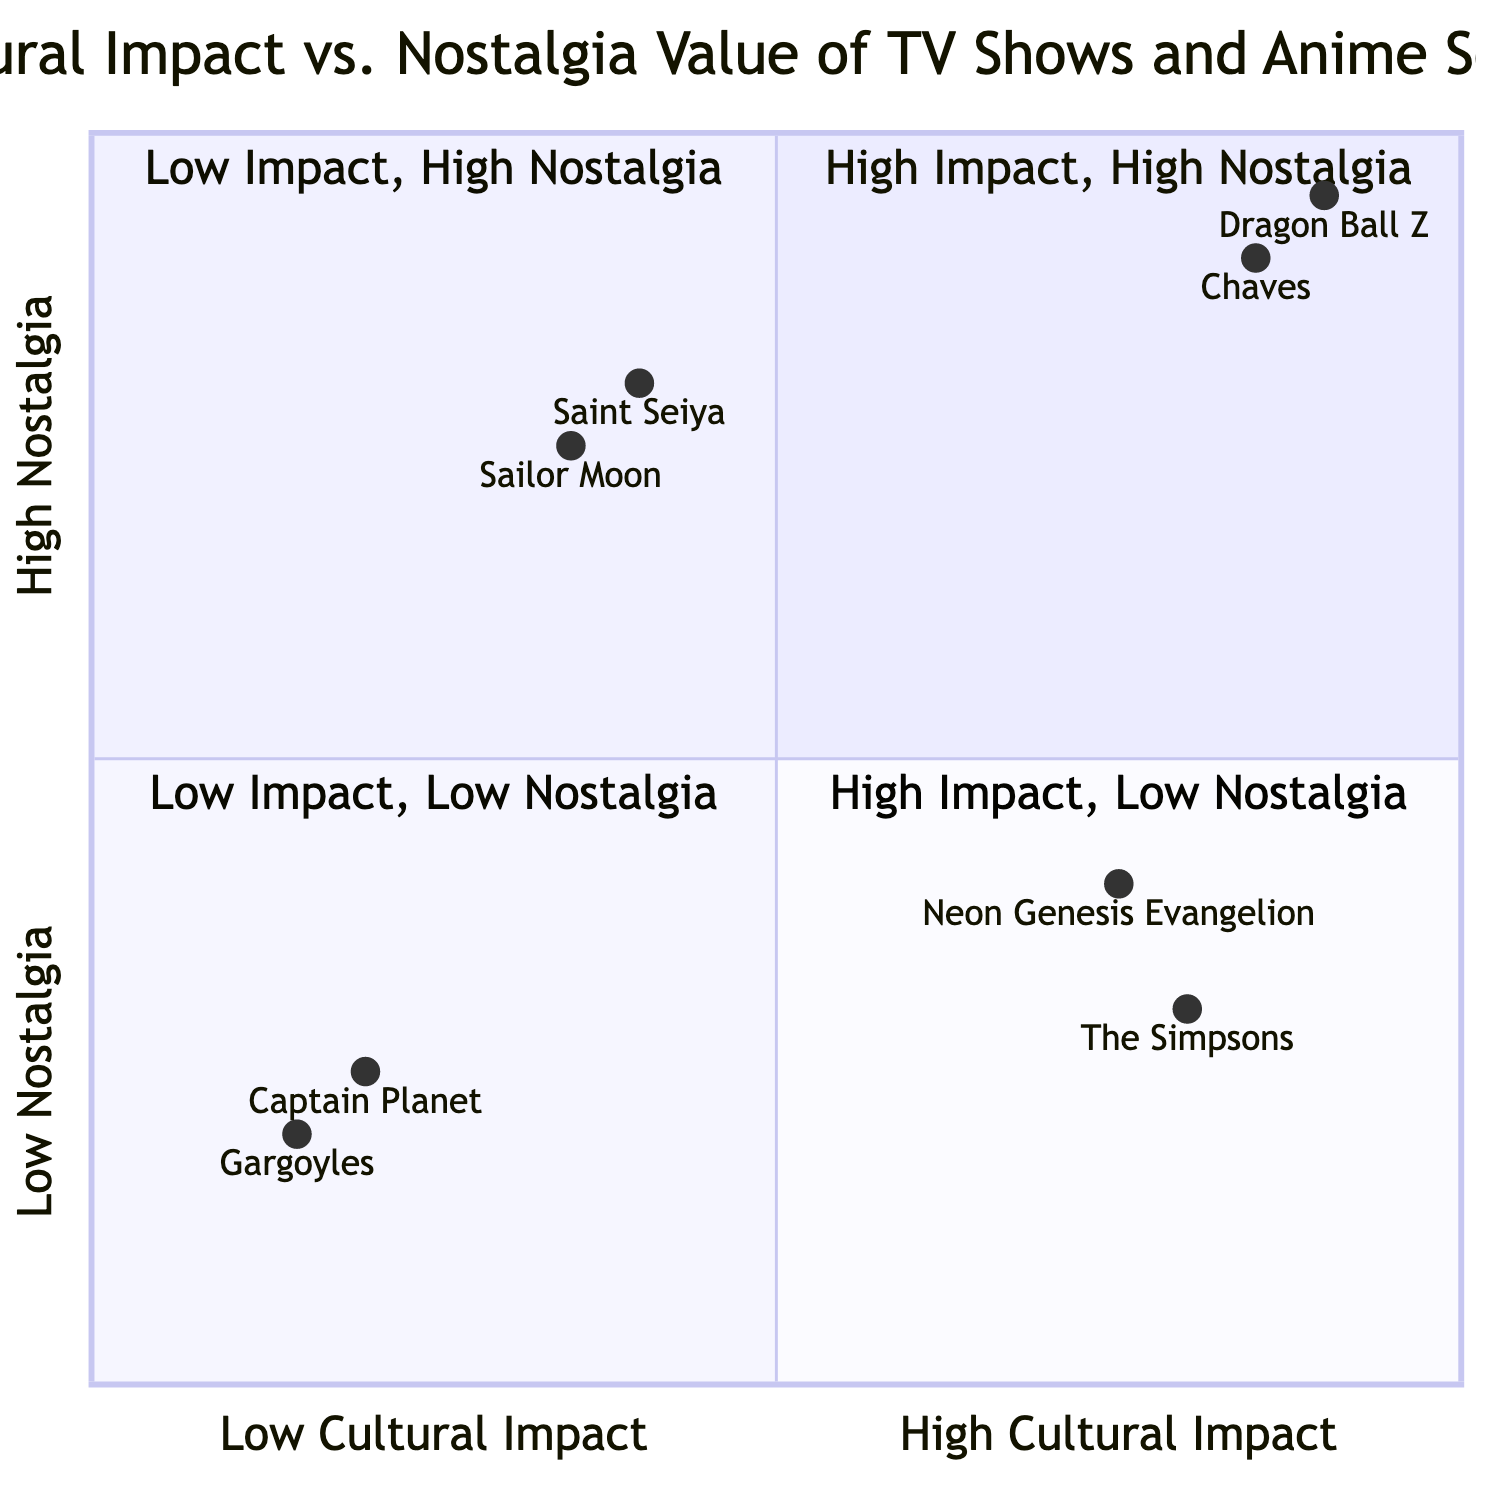What shows are located in the high cultural impact, high nostalgia quadrant? The diagram indicates that "Dragon Ball Z" and "Chaves" are positioned in this quadrant, reflecting their significant impact and high nostalgia value.
Answer: Dragon Ball Z, Chaves Which TV show has the highest nostalgia value? The quadrant chart shows that "Dragon Ball Z" has the highest positioning on the nostalgia axis, indicating it has the highest nostalgia value.
Answer: Dragon Ball Z What is the cultural impact value of "Sailor Moon"? The diagram lists "Sailor Moon" at approximately 0.35 on the cultural impact axis, representing its lower cultural impact.
Answer: 0.35 How many shows are in the low cultural impact, high nostalgia quadrant? The chart displays two shows in the low cultural impact, high nostalgia quadrant: "Saint Seiya" and "Sailor Moon." This indicates a more significant nostalgic value despite their lower cultural impacts.
Answer: 2 Which show has a greater cultural impact: "The Simpsons" or "Neon Genesis Evangelion"? "The Simpsons" is positioned at 0.8 on the cultural impact axis, while "Neon Genesis Evangelion" is lower at 0.75. Hence, "The Simpsons" has a greater cultural impact.
Answer: The Simpsons What is the relationship between "Chaves" and "Saint Seiya" in terms of nostalgia value? "Chaves," located in the high nostalgia quadrant, has an approximate value of 0.9, while "Saint Seiya," although also nostalgic with a value of 0.8, is lower. This shows that "Chaves" has a greater nostalgic value compared to "Saint Seiya."
Answer: Chaves is higher Which quadrant would you find "Captain Planet"? According to the diagram, "Captain Planet" is positioned in the low cultural impact, low nostalgia quadrant, indicating it lacks both significant impact and nostalgic value.
Answer: Low Cultural Impact, Low Nostalgia What is the nostalgia value of "Gargoyles"? "Gargoyles" is placed at approximately 0.2 in the nostalgia dimension, indicating its low nostalgic sentiment.
Answer: 0.2 Which two shows have similar cultural impacts but different nostalgia values? "Neon Genesis Evangelion" with a cultural impact of 0.75 and nostalgia of 0.4, and "The Simpsons" with 0.8 cultural impact but 0.3 nostalgia, show this difference, as they are close in cultural impact yet vary in nostalgia.
Answer: Neon Genesis Evangelion and The Simpsons 